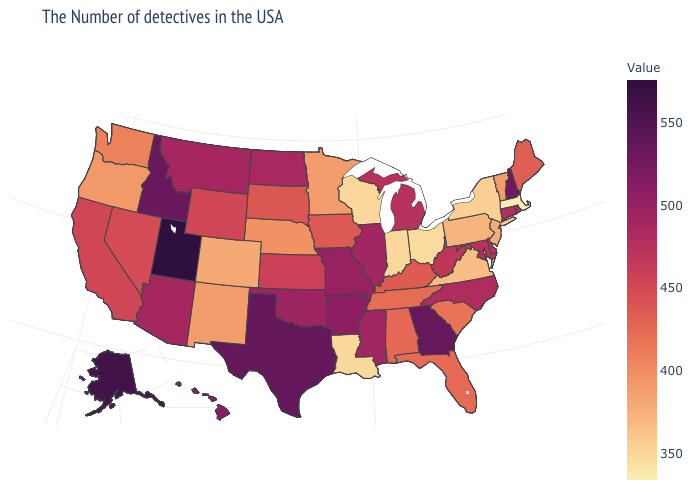Does Iowa have a higher value than Georgia?
Give a very brief answer. No. Among the states that border New Hampshire , which have the highest value?
Write a very short answer. Maine. Does the map have missing data?
Short answer required. No. Is the legend a continuous bar?
Give a very brief answer. Yes. 